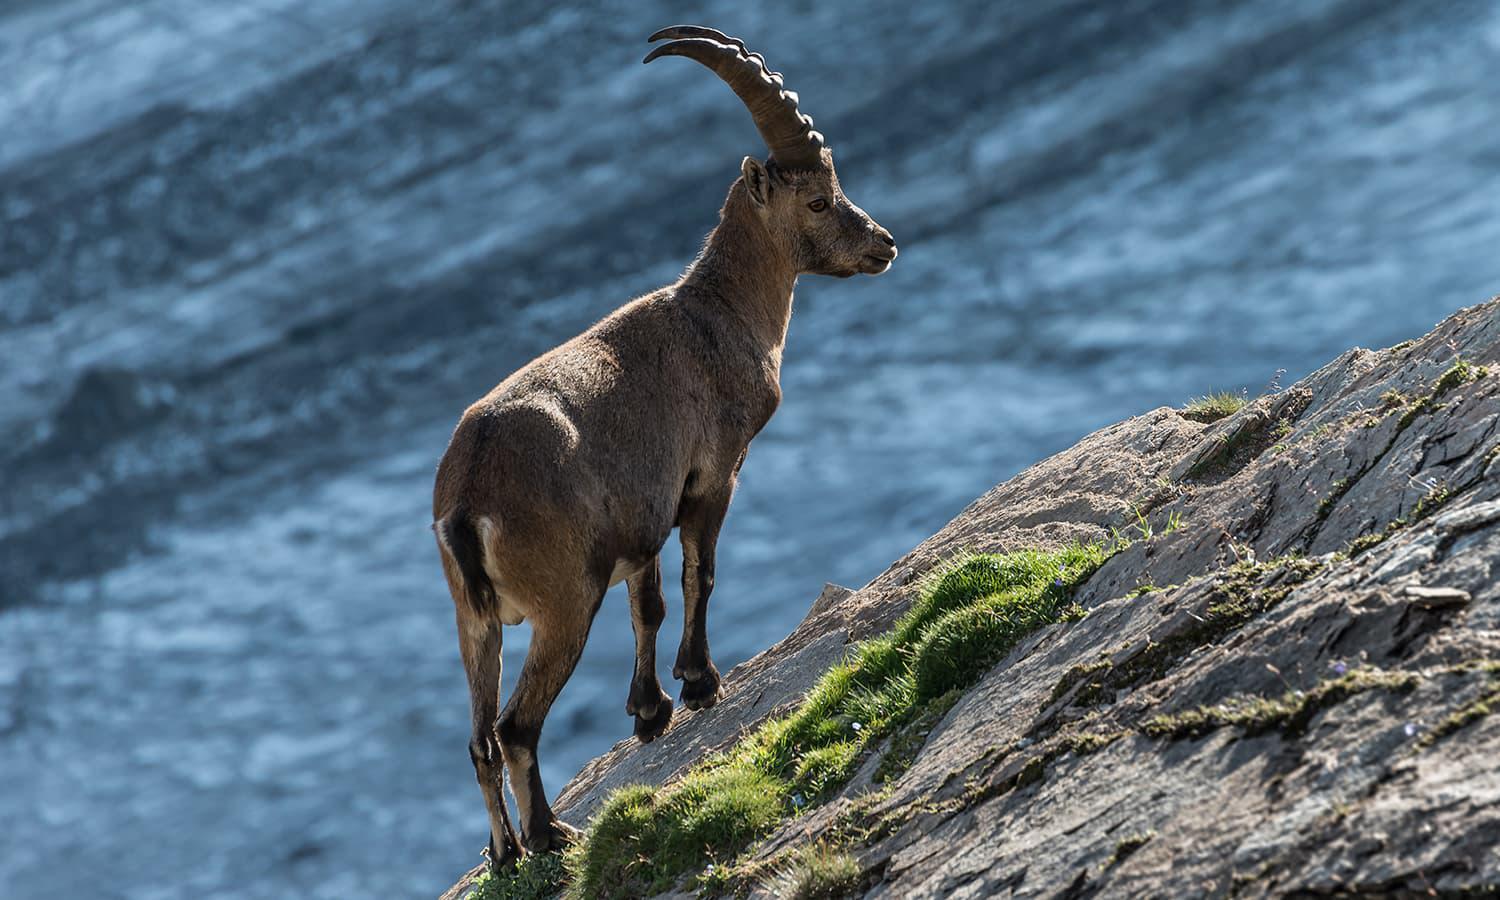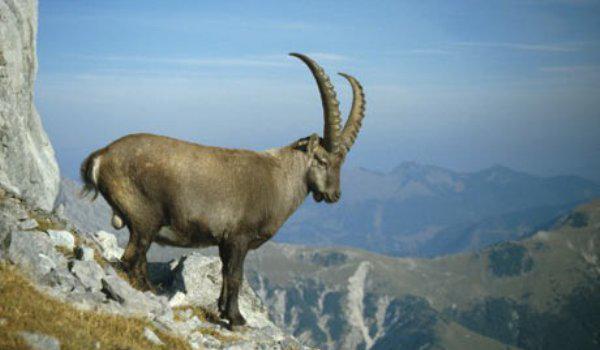The first image is the image on the left, the second image is the image on the right. Given the left and right images, does the statement "All images have a blue background; not a cloud in the sky." hold true? Answer yes or no. No. The first image is the image on the left, the second image is the image on the right. Considering the images on both sides, is "The left image shows one horned animal standing on an inclined rock surface." valid? Answer yes or no. Yes. 